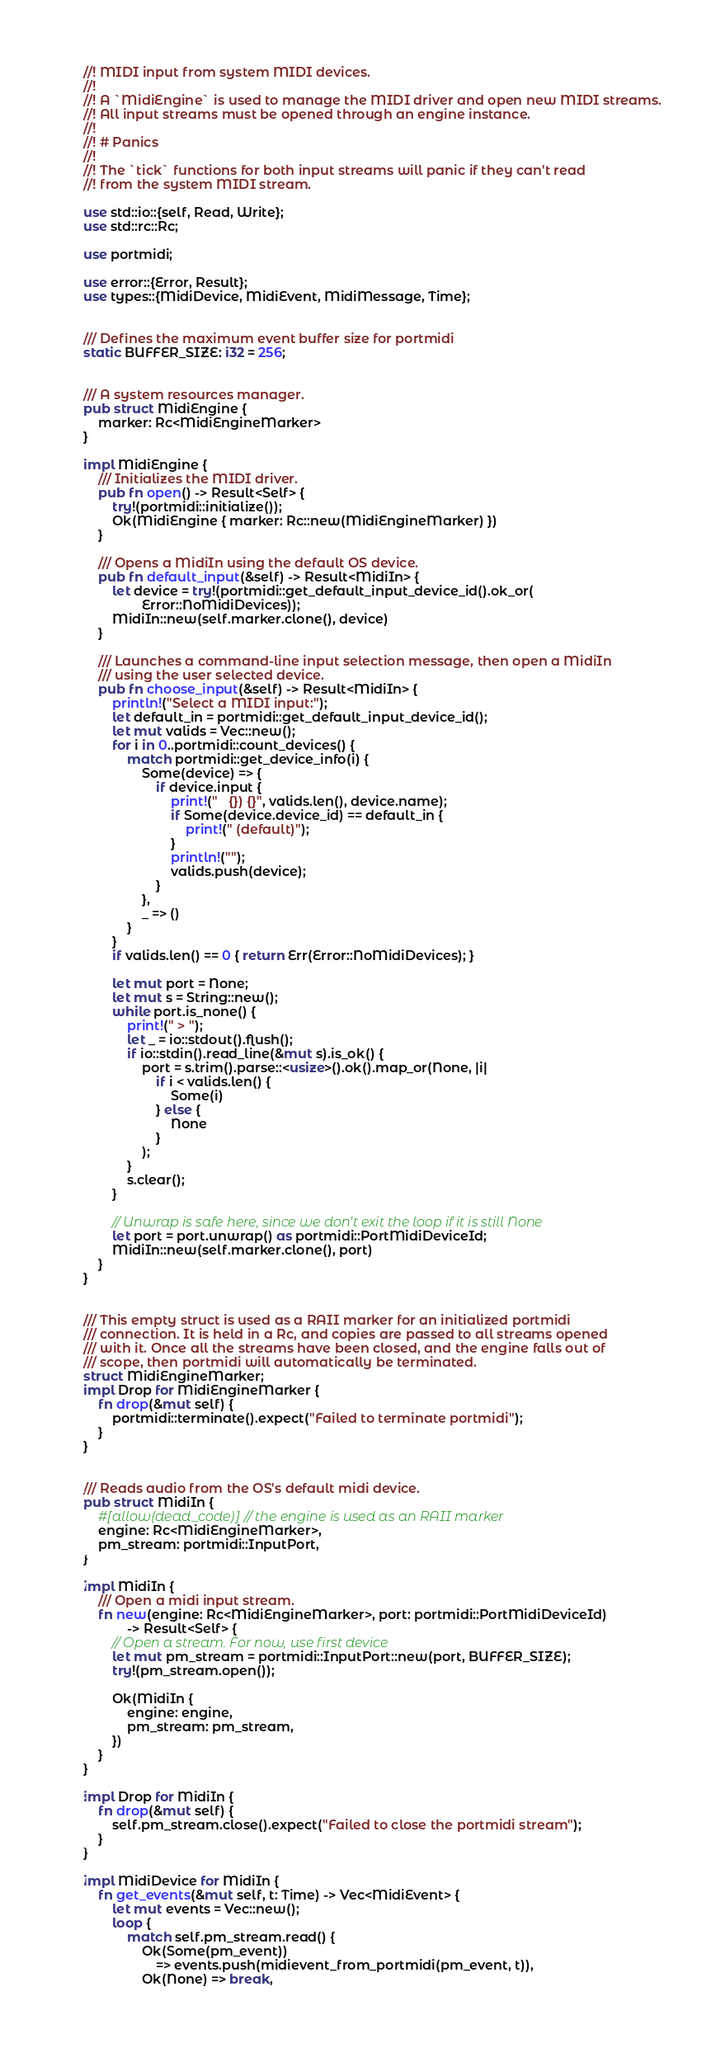<code> <loc_0><loc_0><loc_500><loc_500><_Rust_>//! MIDI input from system MIDI devices.
//!
//! A `MidiEngine` is used to manage the MIDI driver and open new MIDI streams.
//! All input streams must be opened through an engine instance.
//!
//! # Panics
//!
//! The `tick` functions for both input streams will panic if they can't read
//! from the system MIDI stream.

use std::io::{self, Read, Write};
use std::rc::Rc;

use portmidi;

use error::{Error, Result};
use types::{MidiDevice, MidiEvent, MidiMessage, Time};


/// Defines the maximum event buffer size for portmidi
static BUFFER_SIZE: i32 = 256;


/// A system resources manager.
pub struct MidiEngine {
    marker: Rc<MidiEngineMarker>
}

impl MidiEngine {
    /// Initializes the MIDI driver.
    pub fn open() -> Result<Self> {
        try!(portmidi::initialize());
        Ok(MidiEngine { marker: Rc::new(MidiEngineMarker) })
    }

    /// Opens a MidiIn using the default OS device.
    pub fn default_input(&self) -> Result<MidiIn> {
        let device = try!(portmidi::get_default_input_device_id().ok_or(
                Error::NoMidiDevices));
        MidiIn::new(self.marker.clone(), device)
    }

    /// Launches a command-line input selection message, then open a MidiIn
    /// using the user selected device.
    pub fn choose_input(&self) -> Result<MidiIn> {
        println!("Select a MIDI input:");
        let default_in = portmidi::get_default_input_device_id();
        let mut valids = Vec::new();
        for i in 0..portmidi::count_devices() {
            match portmidi::get_device_info(i) {
                Some(device) => {
                    if device.input {
                        print!("   {}) {}", valids.len(), device.name);
                        if Some(device.device_id) == default_in {
                            print!(" (default)");
                        }
                        println!("");
                        valids.push(device);
                    }
                },
                _ => ()
            }
        }
        if valids.len() == 0 { return Err(Error::NoMidiDevices); }

        let mut port = None;
        let mut s = String::new();
        while port.is_none() {
            print!(" > ");
            let _ = io::stdout().flush();
            if io::stdin().read_line(&mut s).is_ok() {
                port = s.trim().parse::<usize>().ok().map_or(None, |i|
                    if i < valids.len() {
                        Some(i)
                    } else {
                        None
                    }
                );
            }
            s.clear();
        }

        // Unwrap is safe here, since we don't exit the loop if it is still None
        let port = port.unwrap() as portmidi::PortMidiDeviceId;
        MidiIn::new(self.marker.clone(), port)
    }
}


/// This empty struct is used as a RAII marker for an initialized portmidi
/// connection. It is held in a Rc, and copies are passed to all streams opened
/// with it. Once all the streams have been closed, and the engine falls out of
/// scope, then portmidi will automatically be terminated.
struct MidiEngineMarker;
impl Drop for MidiEngineMarker {
    fn drop(&mut self) {
        portmidi::terminate().expect("Failed to terminate portmidi");
    }
}


/// Reads audio from the OS's default midi device.
pub struct MidiIn {
    #[allow(dead_code)] // the engine is used as an RAII marker
    engine: Rc<MidiEngineMarker>,
    pm_stream: portmidi::InputPort,
}

impl MidiIn {
    /// Open a midi input stream.
    fn new(engine: Rc<MidiEngineMarker>, port: portmidi::PortMidiDeviceId)
            -> Result<Self> {
        // Open a stream. For now, use first device
        let mut pm_stream = portmidi::InputPort::new(port, BUFFER_SIZE);
        try!(pm_stream.open());

        Ok(MidiIn {
            engine: engine,
            pm_stream: pm_stream,
        })
    }
}

impl Drop for MidiIn {
    fn drop(&mut self) {
        self.pm_stream.close().expect("Failed to close the portmidi stream");
    }
}

impl MidiDevice for MidiIn {
    fn get_events(&mut self, t: Time) -> Vec<MidiEvent> {
        let mut events = Vec::new();
        loop {
            match self.pm_stream.read() {
                Ok(Some(pm_event))
                    => events.push(midievent_from_portmidi(pm_event, t)),
                Ok(None) => break,</code> 